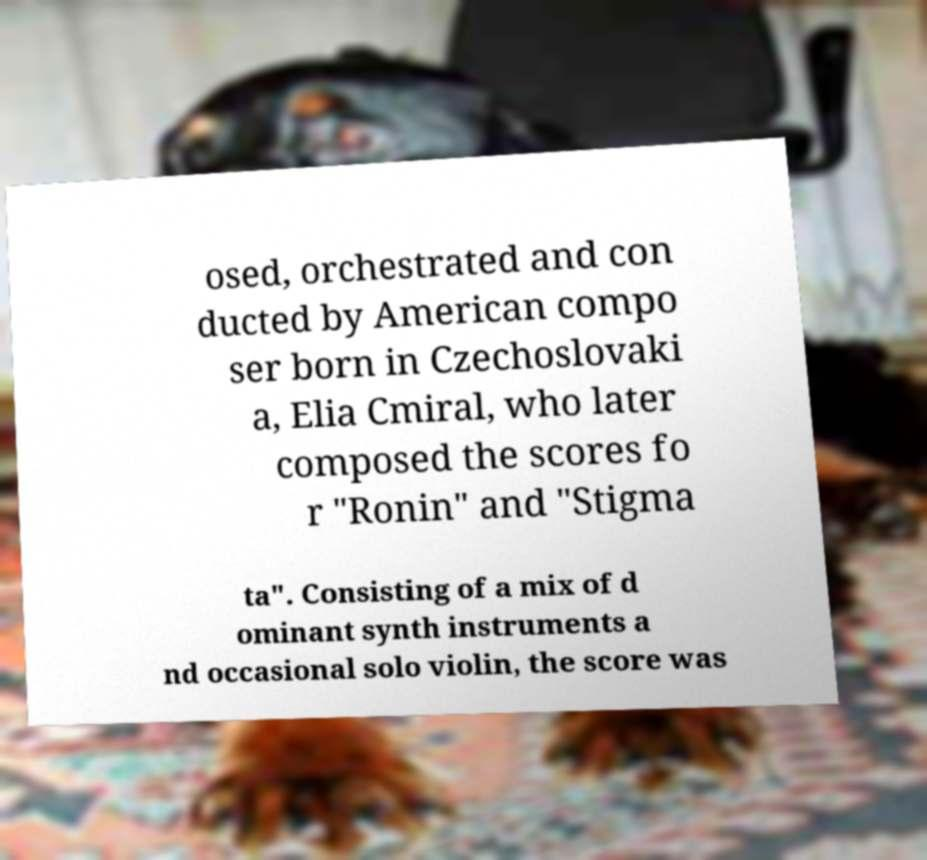Can you accurately transcribe the text from the provided image for me? osed, orchestrated and con ducted by American compo ser born in Czechoslovaki a, Elia Cmiral, who later composed the scores fo r "Ronin" and "Stigma ta". Consisting of a mix of d ominant synth instruments a nd occasional solo violin, the score was 